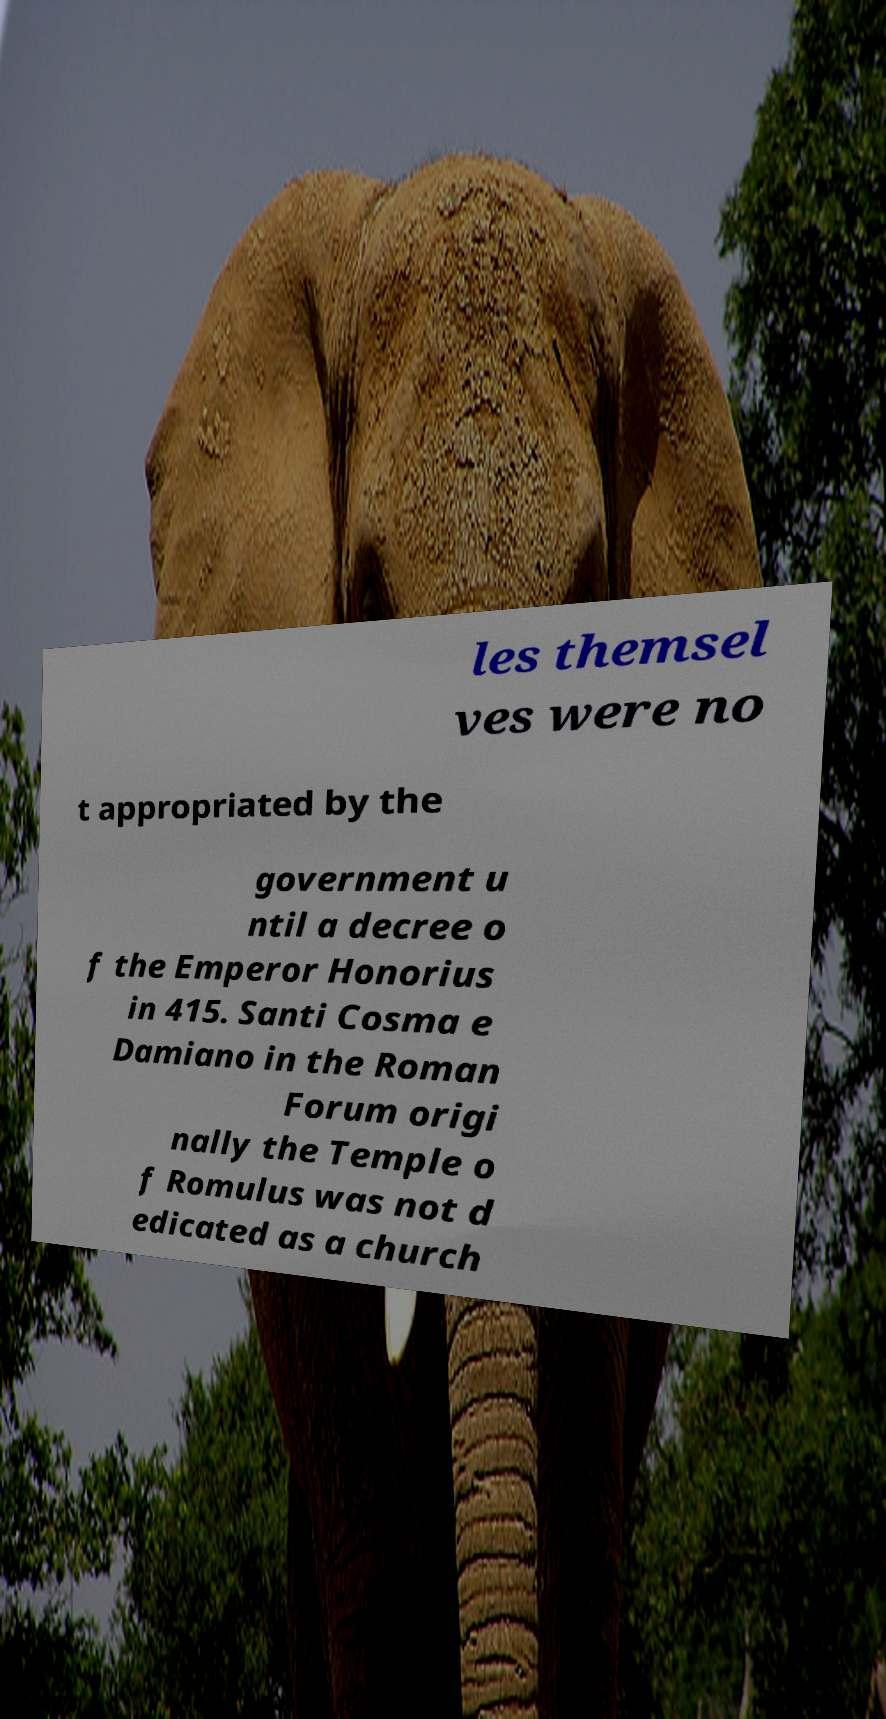What messages or text are displayed in this image? I need them in a readable, typed format. les themsel ves were no t appropriated by the government u ntil a decree o f the Emperor Honorius in 415. Santi Cosma e Damiano in the Roman Forum origi nally the Temple o f Romulus was not d edicated as a church 